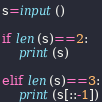<code> <loc_0><loc_0><loc_500><loc_500><_Python_>s=input()

if len(s)==2:
    print(s)

elif len(s)==3:
    print(s[::-1])</code> 